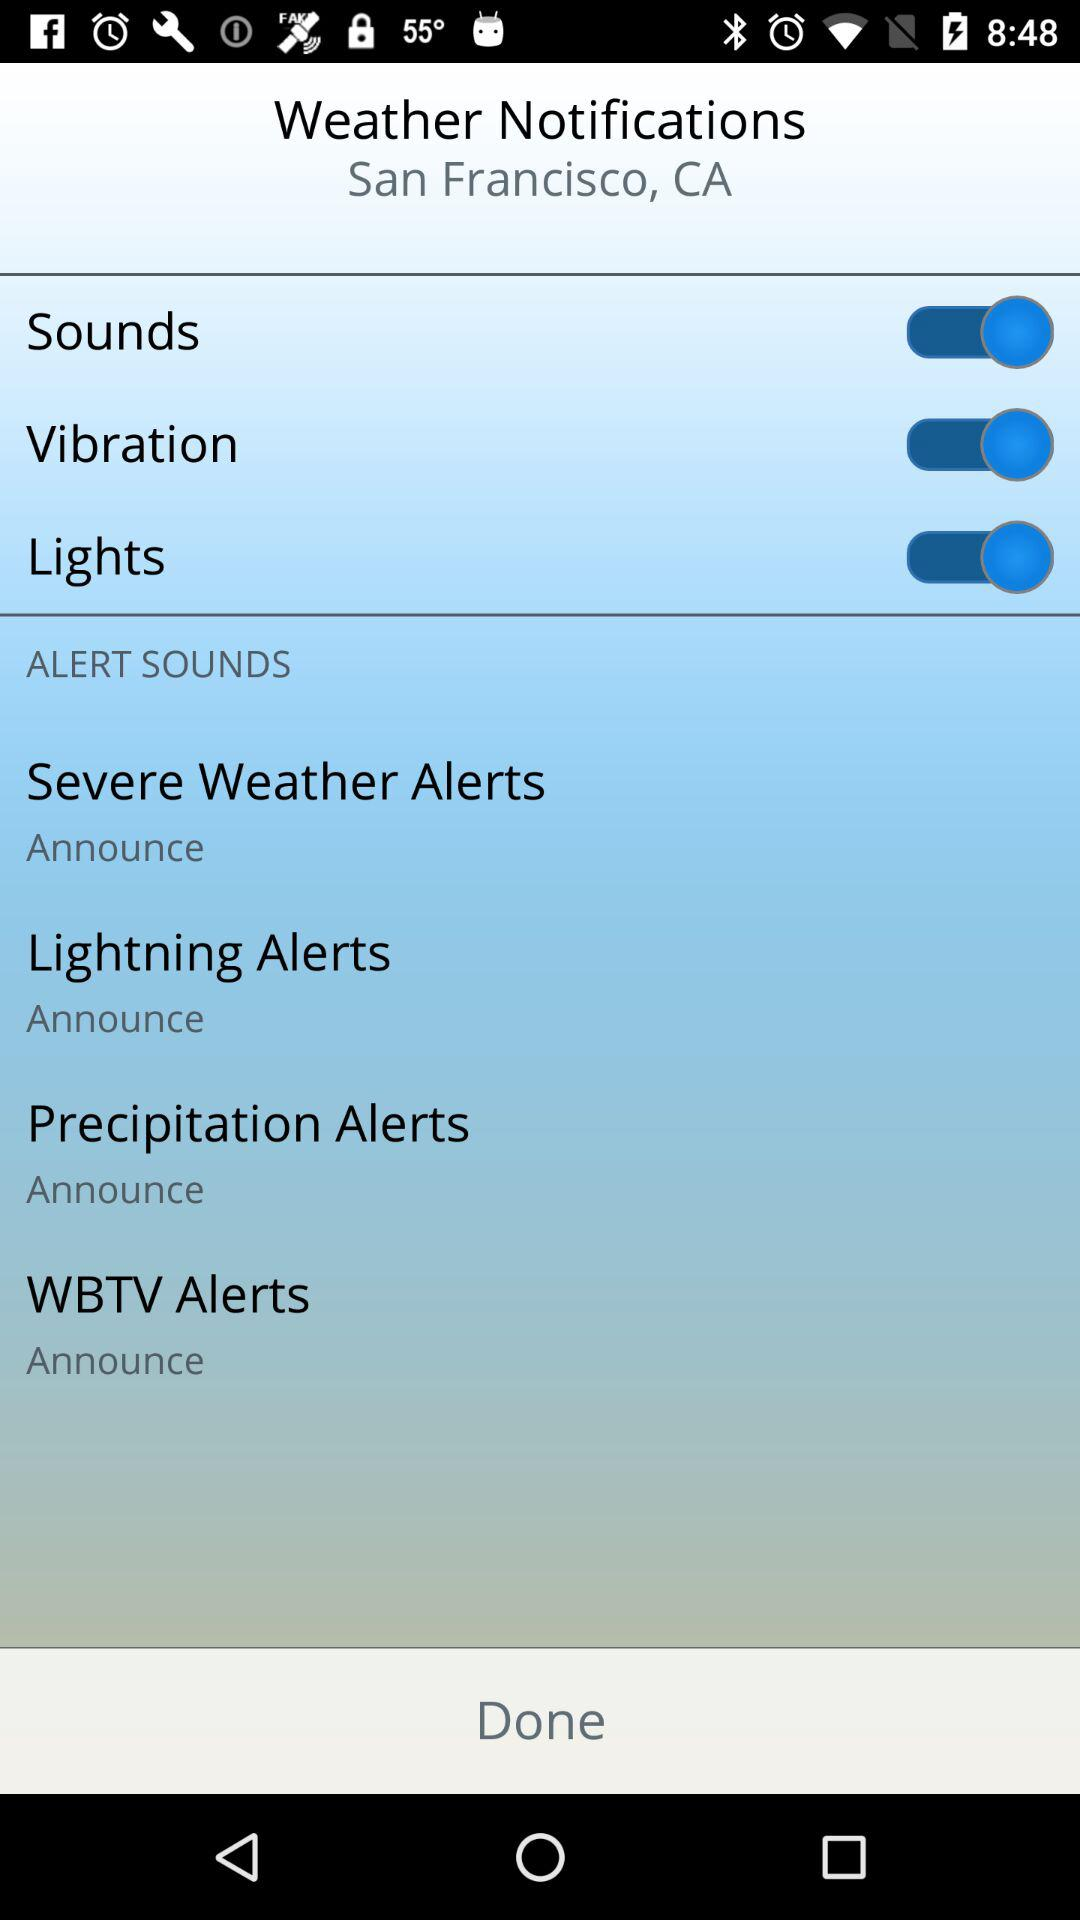Which options are enabled under the weather notifications? The enabled options are "Sounds", "Vibration" and "Lights". 